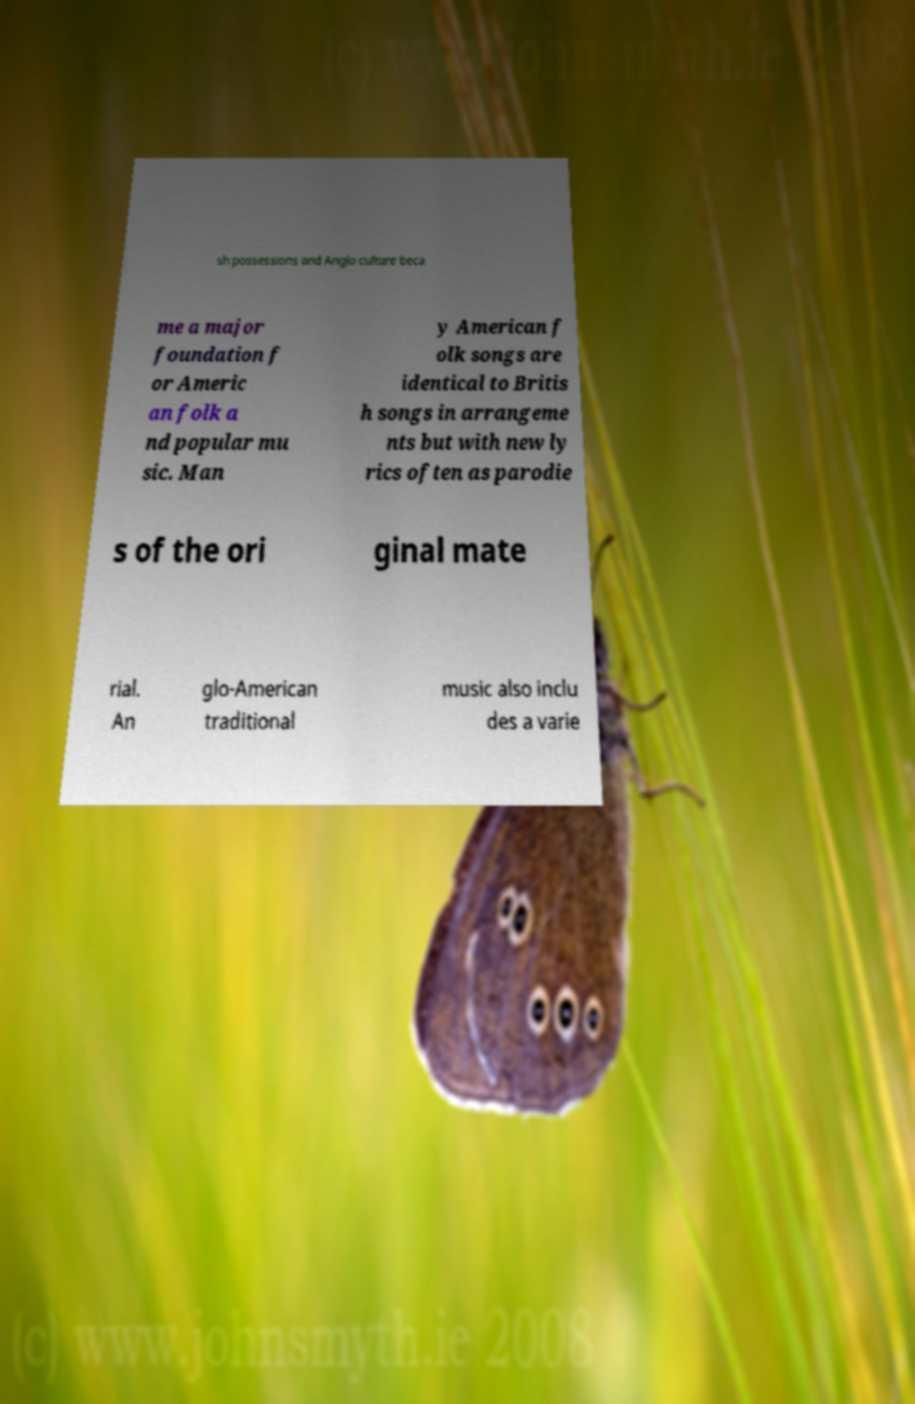Can you accurately transcribe the text from the provided image for me? sh possessions and Anglo culture beca me a major foundation f or Americ an folk a nd popular mu sic. Man y American f olk songs are identical to Britis h songs in arrangeme nts but with new ly rics often as parodie s of the ori ginal mate rial. An glo-American traditional music also inclu des a varie 